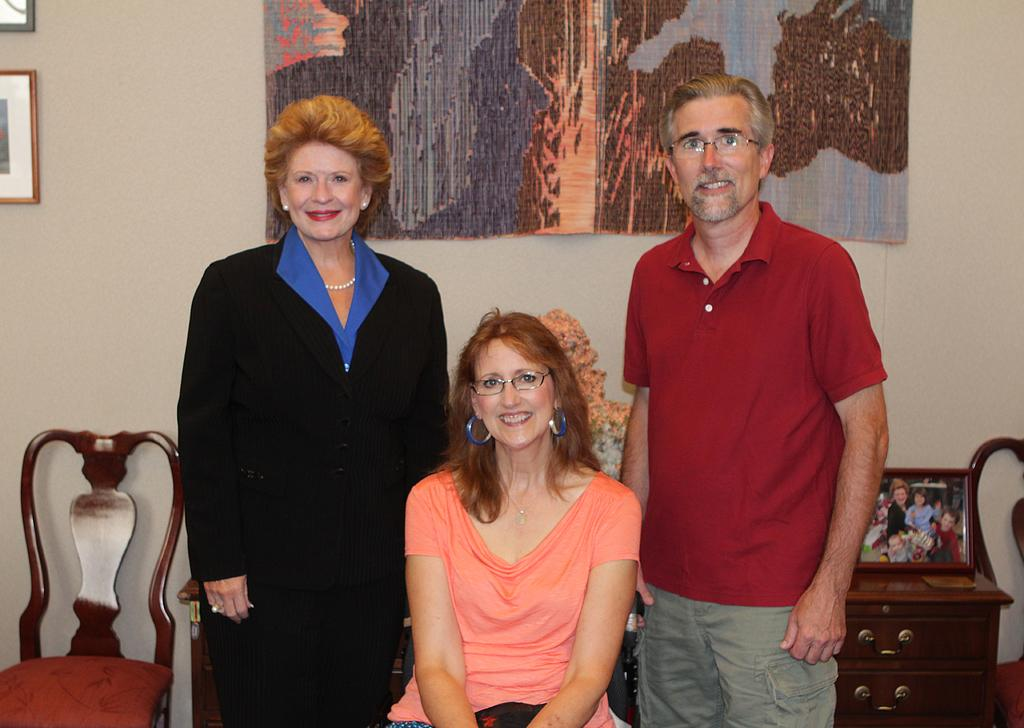How many people are in the image? There are three persons in the middle of the image. What furniture can be seen in the image? There is a chair, a cupboard, and a flower vase in the image. What type of decorative items are present in the image? There are frames in the image. What architectural feature is visible in the image? There is a wall in the image. How many pieces of lumber are stacked against the wall in the image? There is no lumber present in the image. What type of cats can be seen playing with the frames in the image? There are no cats present in the image. 